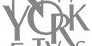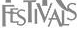Transcribe the words shown in these images in order, separated by a semicolon. YORK; FESTIVALS 